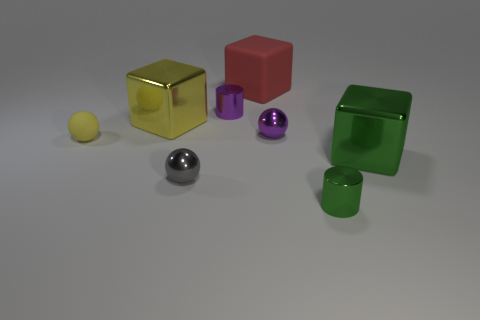What color is the other matte thing that is the same shape as the large green object?
Your response must be concise. Red. Is the yellow shiny cube the same size as the purple sphere?
Provide a short and direct response. No. How many other things are the same size as the yellow cube?
Provide a succinct answer. 2. What number of objects are either spheres that are left of the red rubber thing or things that are to the left of the big green object?
Your response must be concise. 7. The green thing that is the same size as the yellow ball is what shape?
Ensure brevity in your answer.  Cylinder. What is the size of the gray sphere that is made of the same material as the small green cylinder?
Your response must be concise. Small. Is the shape of the big matte thing the same as the yellow metallic thing?
Your response must be concise. Yes. There is a rubber sphere that is the same size as the green cylinder; what color is it?
Offer a terse response. Yellow. What is the size of the other gray thing that is the same shape as the small matte thing?
Ensure brevity in your answer.  Small. The green thing that is behind the small gray sphere has what shape?
Provide a succinct answer. Cube. 